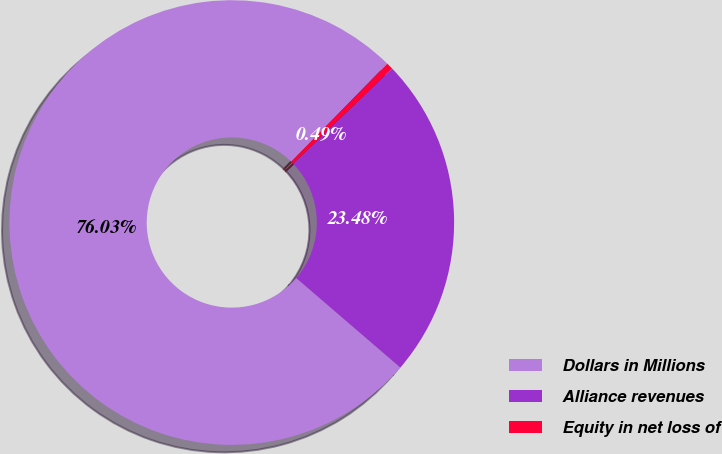Convert chart to OTSL. <chart><loc_0><loc_0><loc_500><loc_500><pie_chart><fcel>Dollars in Millions<fcel>Alliance revenues<fcel>Equity in net loss of<nl><fcel>76.03%<fcel>23.48%<fcel>0.49%<nl></chart> 